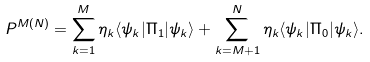<formula> <loc_0><loc_0><loc_500><loc_500>P ^ { M ( N ) } = \sum _ { k = 1 } ^ { M } \eta _ { k } \langle \psi _ { k } | \Pi _ { 1 } | \psi _ { k } \rangle + \sum _ { k = M + 1 } ^ { N } \eta _ { k } \langle \psi _ { k } | \Pi _ { 0 } | \psi _ { k } \rangle .</formula> 